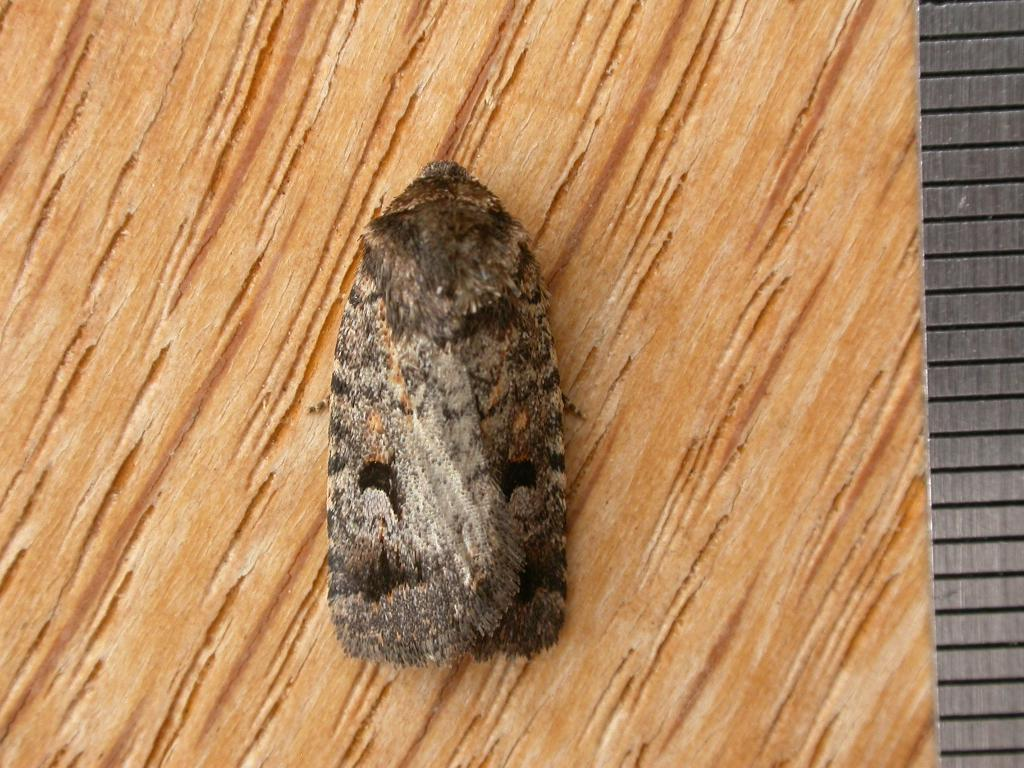What type of creature can be seen in the image? There is an insect in the image. Where is the insect located? The insect is sitting on a wooden surface. How does the insect feel about the wooden surface? There is no way to determine the insect's feelings about the wooden surface from the image. 